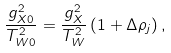Convert formula to latex. <formula><loc_0><loc_0><loc_500><loc_500>\frac { g _ { X 0 } ^ { 2 } } { T _ { W 0 } ^ { 2 } } = \frac { g _ { X } ^ { 2 } } { T _ { W } ^ { 2 } } \left ( 1 + \Delta \rho _ { j } \right ) ,</formula> 